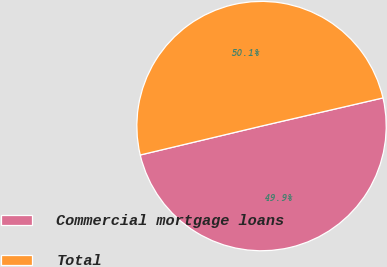<chart> <loc_0><loc_0><loc_500><loc_500><pie_chart><fcel>Commercial mortgage loans<fcel>Total<nl><fcel>49.9%<fcel>50.1%<nl></chart> 